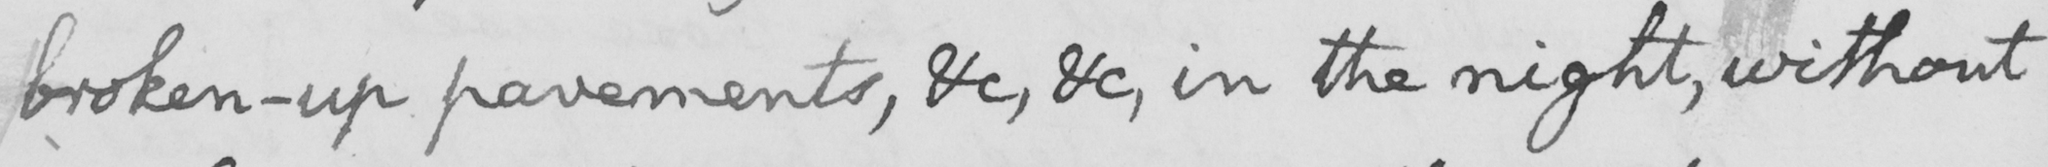Please transcribe the handwritten text in this image. broken-up pavements , &c , &c , in the night , without 